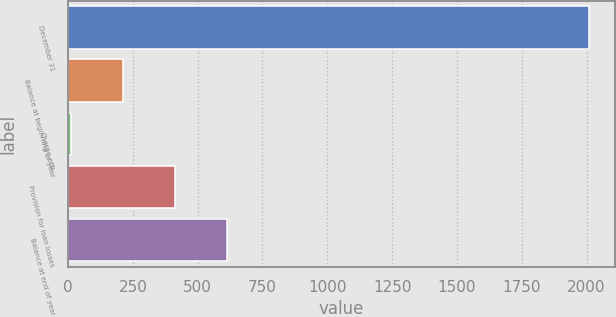Convert chart. <chart><loc_0><loc_0><loc_500><loc_500><bar_chart><fcel>December 31<fcel>Balance at beginning of year<fcel>Charge-offs<fcel>Provision for loan losses<fcel>Balance at end of year<nl><fcel>2009<fcel>212.6<fcel>13<fcel>412.2<fcel>611.8<nl></chart> 